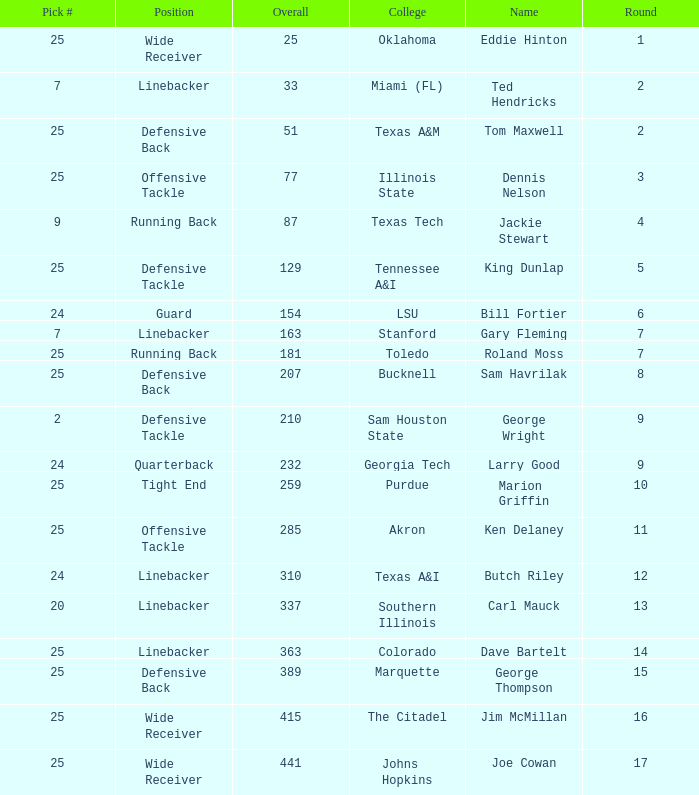College of lsu has how many rounds? 1.0. 